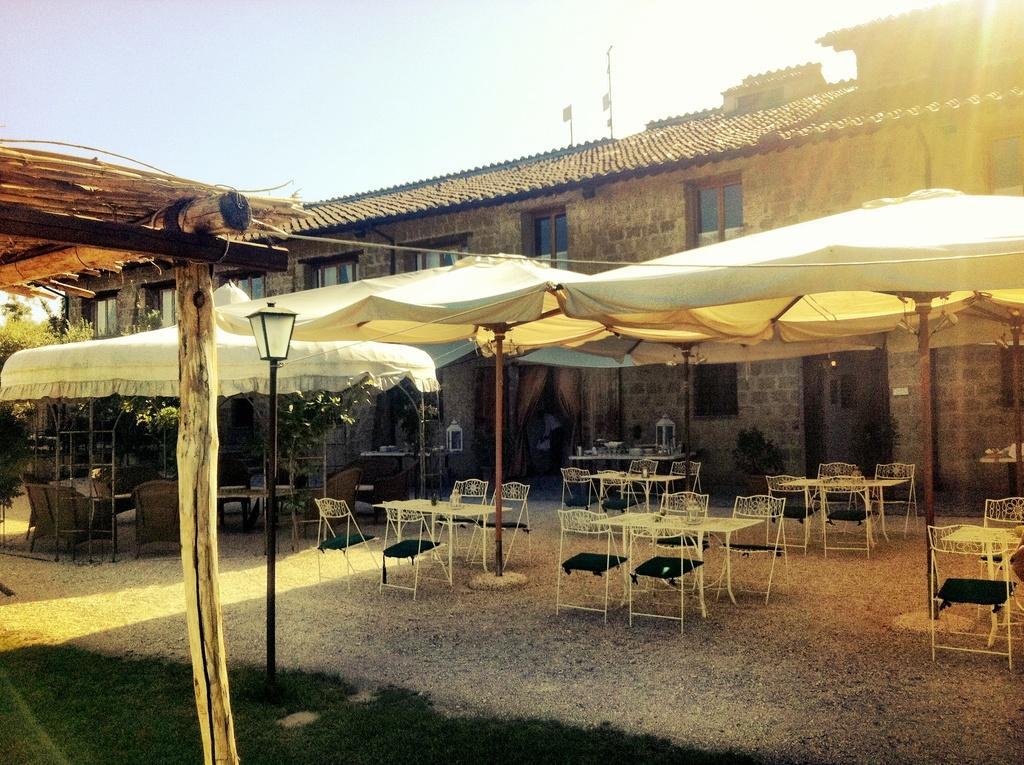Please provide a concise description of this image. In this image I can see the grass. I can see some objects on the table. I can see the chairs. I can also see the plants. In the background, I can see the tents and a house with the windows. At the top I can see the sky. 